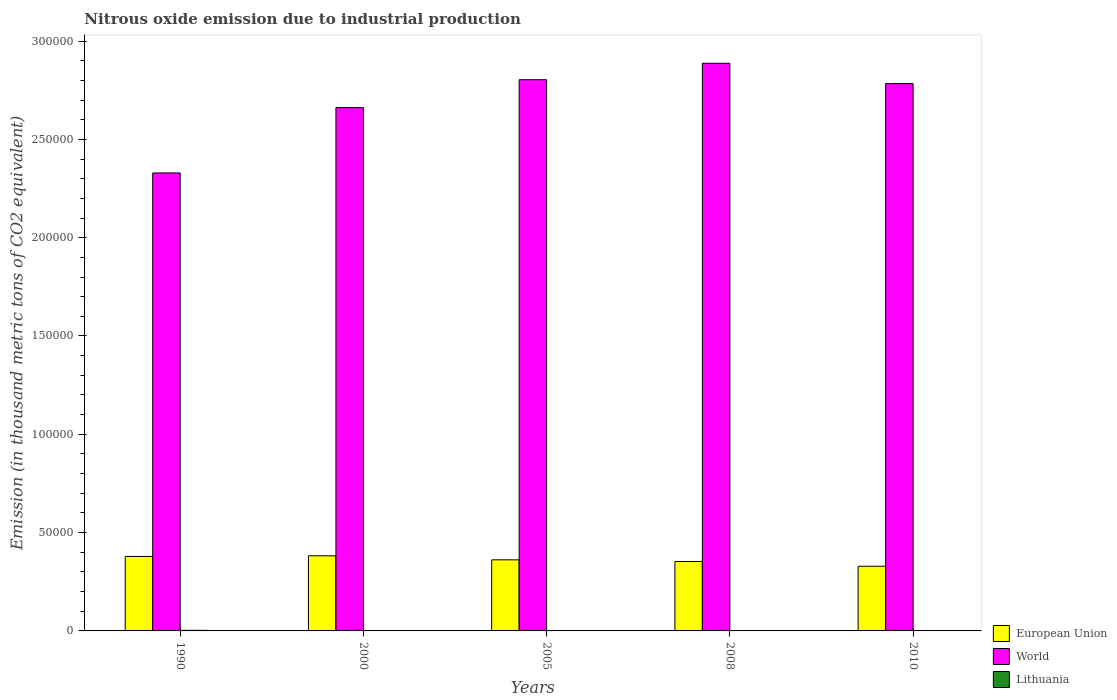How many different coloured bars are there?
Your response must be concise. 3. How many groups of bars are there?
Your response must be concise. 5. Are the number of bars per tick equal to the number of legend labels?
Give a very brief answer. Yes. Are the number of bars on each tick of the X-axis equal?
Provide a succinct answer. Yes. How many bars are there on the 1st tick from the left?
Give a very brief answer. 3. How many bars are there on the 5th tick from the right?
Your response must be concise. 3. In how many cases, is the number of bars for a given year not equal to the number of legend labels?
Provide a succinct answer. 0. What is the amount of nitrous oxide emitted in European Union in 2005?
Your answer should be very brief. 3.62e+04. Across all years, what is the maximum amount of nitrous oxide emitted in World?
Offer a terse response. 2.89e+05. Across all years, what is the minimum amount of nitrous oxide emitted in World?
Your answer should be compact. 2.33e+05. What is the total amount of nitrous oxide emitted in World in the graph?
Provide a short and direct response. 1.35e+06. What is the difference between the amount of nitrous oxide emitted in Lithuania in 2000 and that in 2010?
Offer a terse response. -2.5. What is the difference between the amount of nitrous oxide emitted in European Union in 2000 and the amount of nitrous oxide emitted in World in 2010?
Offer a very short reply. -2.40e+05. What is the average amount of nitrous oxide emitted in Lithuania per year?
Give a very brief answer. 153.16. In the year 2008, what is the difference between the amount of nitrous oxide emitted in Lithuania and amount of nitrous oxide emitted in European Union?
Make the answer very short. -3.52e+04. In how many years, is the amount of nitrous oxide emitted in Lithuania greater than 220000 thousand metric tons?
Your response must be concise. 0. What is the ratio of the amount of nitrous oxide emitted in European Union in 2000 to that in 2008?
Give a very brief answer. 1.08. What is the difference between the highest and the second highest amount of nitrous oxide emitted in European Union?
Give a very brief answer. 328.9. What is the difference between the highest and the lowest amount of nitrous oxide emitted in Lithuania?
Offer a terse response. 184.9. Is the sum of the amount of nitrous oxide emitted in World in 2000 and 2008 greater than the maximum amount of nitrous oxide emitted in European Union across all years?
Your answer should be compact. Yes. What does the 3rd bar from the left in 1990 represents?
Give a very brief answer. Lithuania. What does the 3rd bar from the right in 2010 represents?
Keep it short and to the point. European Union. Are all the bars in the graph horizontal?
Ensure brevity in your answer.  No. How many years are there in the graph?
Keep it short and to the point. 5. What is the difference between two consecutive major ticks on the Y-axis?
Ensure brevity in your answer.  5.00e+04. Does the graph contain any zero values?
Your response must be concise. No. Does the graph contain grids?
Ensure brevity in your answer.  No. Where does the legend appear in the graph?
Your answer should be compact. Bottom right. How many legend labels are there?
Make the answer very short. 3. How are the legend labels stacked?
Give a very brief answer. Vertical. What is the title of the graph?
Give a very brief answer. Nitrous oxide emission due to industrial production. Does "Syrian Arab Republic" appear as one of the legend labels in the graph?
Provide a short and direct response. No. What is the label or title of the X-axis?
Keep it short and to the point. Years. What is the label or title of the Y-axis?
Your answer should be compact. Emission (in thousand metric tons of CO2 equivalent). What is the Emission (in thousand metric tons of CO2 equivalent) of European Union in 1990?
Provide a succinct answer. 3.79e+04. What is the Emission (in thousand metric tons of CO2 equivalent) of World in 1990?
Make the answer very short. 2.33e+05. What is the Emission (in thousand metric tons of CO2 equivalent) of Lithuania in 1990?
Provide a succinct answer. 295.2. What is the Emission (in thousand metric tons of CO2 equivalent) of European Union in 2000?
Give a very brief answer. 3.82e+04. What is the Emission (in thousand metric tons of CO2 equivalent) in World in 2000?
Provide a short and direct response. 2.66e+05. What is the Emission (in thousand metric tons of CO2 equivalent) in Lithuania in 2000?
Make the answer very short. 110.3. What is the Emission (in thousand metric tons of CO2 equivalent) in European Union in 2005?
Your answer should be compact. 3.62e+04. What is the Emission (in thousand metric tons of CO2 equivalent) of World in 2005?
Give a very brief answer. 2.80e+05. What is the Emission (in thousand metric tons of CO2 equivalent) in Lithuania in 2005?
Your answer should be very brief. 119.6. What is the Emission (in thousand metric tons of CO2 equivalent) in European Union in 2008?
Your answer should be very brief. 3.53e+04. What is the Emission (in thousand metric tons of CO2 equivalent) of World in 2008?
Offer a terse response. 2.89e+05. What is the Emission (in thousand metric tons of CO2 equivalent) of Lithuania in 2008?
Your response must be concise. 127.9. What is the Emission (in thousand metric tons of CO2 equivalent) in European Union in 2010?
Make the answer very short. 3.29e+04. What is the Emission (in thousand metric tons of CO2 equivalent) of World in 2010?
Your answer should be very brief. 2.78e+05. What is the Emission (in thousand metric tons of CO2 equivalent) in Lithuania in 2010?
Ensure brevity in your answer.  112.8. Across all years, what is the maximum Emission (in thousand metric tons of CO2 equivalent) in European Union?
Ensure brevity in your answer.  3.82e+04. Across all years, what is the maximum Emission (in thousand metric tons of CO2 equivalent) in World?
Provide a short and direct response. 2.89e+05. Across all years, what is the maximum Emission (in thousand metric tons of CO2 equivalent) in Lithuania?
Provide a succinct answer. 295.2. Across all years, what is the minimum Emission (in thousand metric tons of CO2 equivalent) in European Union?
Your response must be concise. 3.29e+04. Across all years, what is the minimum Emission (in thousand metric tons of CO2 equivalent) of World?
Your answer should be compact. 2.33e+05. Across all years, what is the minimum Emission (in thousand metric tons of CO2 equivalent) in Lithuania?
Your response must be concise. 110.3. What is the total Emission (in thousand metric tons of CO2 equivalent) in European Union in the graph?
Your answer should be very brief. 1.80e+05. What is the total Emission (in thousand metric tons of CO2 equivalent) in World in the graph?
Offer a terse response. 1.35e+06. What is the total Emission (in thousand metric tons of CO2 equivalent) in Lithuania in the graph?
Provide a short and direct response. 765.8. What is the difference between the Emission (in thousand metric tons of CO2 equivalent) in European Union in 1990 and that in 2000?
Provide a succinct answer. -328.9. What is the difference between the Emission (in thousand metric tons of CO2 equivalent) in World in 1990 and that in 2000?
Keep it short and to the point. -3.32e+04. What is the difference between the Emission (in thousand metric tons of CO2 equivalent) of Lithuania in 1990 and that in 2000?
Keep it short and to the point. 184.9. What is the difference between the Emission (in thousand metric tons of CO2 equivalent) of European Union in 1990 and that in 2005?
Provide a short and direct response. 1721.7. What is the difference between the Emission (in thousand metric tons of CO2 equivalent) in World in 1990 and that in 2005?
Give a very brief answer. -4.74e+04. What is the difference between the Emission (in thousand metric tons of CO2 equivalent) in Lithuania in 1990 and that in 2005?
Your answer should be compact. 175.6. What is the difference between the Emission (in thousand metric tons of CO2 equivalent) of European Union in 1990 and that in 2008?
Keep it short and to the point. 2566.7. What is the difference between the Emission (in thousand metric tons of CO2 equivalent) of World in 1990 and that in 2008?
Your answer should be very brief. -5.58e+04. What is the difference between the Emission (in thousand metric tons of CO2 equivalent) in Lithuania in 1990 and that in 2008?
Your answer should be very brief. 167.3. What is the difference between the Emission (in thousand metric tons of CO2 equivalent) of European Union in 1990 and that in 2010?
Your response must be concise. 4969.2. What is the difference between the Emission (in thousand metric tons of CO2 equivalent) of World in 1990 and that in 2010?
Your answer should be very brief. -4.55e+04. What is the difference between the Emission (in thousand metric tons of CO2 equivalent) in Lithuania in 1990 and that in 2010?
Ensure brevity in your answer.  182.4. What is the difference between the Emission (in thousand metric tons of CO2 equivalent) in European Union in 2000 and that in 2005?
Your answer should be compact. 2050.6. What is the difference between the Emission (in thousand metric tons of CO2 equivalent) in World in 2000 and that in 2005?
Provide a succinct answer. -1.42e+04. What is the difference between the Emission (in thousand metric tons of CO2 equivalent) of Lithuania in 2000 and that in 2005?
Keep it short and to the point. -9.3. What is the difference between the Emission (in thousand metric tons of CO2 equivalent) of European Union in 2000 and that in 2008?
Give a very brief answer. 2895.6. What is the difference between the Emission (in thousand metric tons of CO2 equivalent) of World in 2000 and that in 2008?
Give a very brief answer. -2.25e+04. What is the difference between the Emission (in thousand metric tons of CO2 equivalent) in Lithuania in 2000 and that in 2008?
Provide a short and direct response. -17.6. What is the difference between the Emission (in thousand metric tons of CO2 equivalent) in European Union in 2000 and that in 2010?
Your answer should be compact. 5298.1. What is the difference between the Emission (in thousand metric tons of CO2 equivalent) of World in 2000 and that in 2010?
Your answer should be very brief. -1.22e+04. What is the difference between the Emission (in thousand metric tons of CO2 equivalent) of European Union in 2005 and that in 2008?
Provide a succinct answer. 845. What is the difference between the Emission (in thousand metric tons of CO2 equivalent) in World in 2005 and that in 2008?
Provide a short and direct response. -8372.6. What is the difference between the Emission (in thousand metric tons of CO2 equivalent) in Lithuania in 2005 and that in 2008?
Ensure brevity in your answer.  -8.3. What is the difference between the Emission (in thousand metric tons of CO2 equivalent) in European Union in 2005 and that in 2010?
Offer a terse response. 3247.5. What is the difference between the Emission (in thousand metric tons of CO2 equivalent) in World in 2005 and that in 2010?
Provide a short and direct response. 1963.1. What is the difference between the Emission (in thousand metric tons of CO2 equivalent) of Lithuania in 2005 and that in 2010?
Offer a terse response. 6.8. What is the difference between the Emission (in thousand metric tons of CO2 equivalent) of European Union in 2008 and that in 2010?
Your response must be concise. 2402.5. What is the difference between the Emission (in thousand metric tons of CO2 equivalent) of World in 2008 and that in 2010?
Offer a terse response. 1.03e+04. What is the difference between the Emission (in thousand metric tons of CO2 equivalent) of Lithuania in 2008 and that in 2010?
Give a very brief answer. 15.1. What is the difference between the Emission (in thousand metric tons of CO2 equivalent) of European Union in 1990 and the Emission (in thousand metric tons of CO2 equivalent) of World in 2000?
Your answer should be compact. -2.28e+05. What is the difference between the Emission (in thousand metric tons of CO2 equivalent) of European Union in 1990 and the Emission (in thousand metric tons of CO2 equivalent) of Lithuania in 2000?
Provide a succinct answer. 3.78e+04. What is the difference between the Emission (in thousand metric tons of CO2 equivalent) of World in 1990 and the Emission (in thousand metric tons of CO2 equivalent) of Lithuania in 2000?
Offer a terse response. 2.33e+05. What is the difference between the Emission (in thousand metric tons of CO2 equivalent) of European Union in 1990 and the Emission (in thousand metric tons of CO2 equivalent) of World in 2005?
Provide a succinct answer. -2.42e+05. What is the difference between the Emission (in thousand metric tons of CO2 equivalent) of European Union in 1990 and the Emission (in thousand metric tons of CO2 equivalent) of Lithuania in 2005?
Your response must be concise. 3.78e+04. What is the difference between the Emission (in thousand metric tons of CO2 equivalent) of World in 1990 and the Emission (in thousand metric tons of CO2 equivalent) of Lithuania in 2005?
Offer a very short reply. 2.33e+05. What is the difference between the Emission (in thousand metric tons of CO2 equivalent) of European Union in 1990 and the Emission (in thousand metric tons of CO2 equivalent) of World in 2008?
Your answer should be compact. -2.51e+05. What is the difference between the Emission (in thousand metric tons of CO2 equivalent) of European Union in 1990 and the Emission (in thousand metric tons of CO2 equivalent) of Lithuania in 2008?
Make the answer very short. 3.77e+04. What is the difference between the Emission (in thousand metric tons of CO2 equivalent) in World in 1990 and the Emission (in thousand metric tons of CO2 equivalent) in Lithuania in 2008?
Offer a very short reply. 2.33e+05. What is the difference between the Emission (in thousand metric tons of CO2 equivalent) of European Union in 1990 and the Emission (in thousand metric tons of CO2 equivalent) of World in 2010?
Offer a terse response. -2.40e+05. What is the difference between the Emission (in thousand metric tons of CO2 equivalent) of European Union in 1990 and the Emission (in thousand metric tons of CO2 equivalent) of Lithuania in 2010?
Your answer should be compact. 3.78e+04. What is the difference between the Emission (in thousand metric tons of CO2 equivalent) of World in 1990 and the Emission (in thousand metric tons of CO2 equivalent) of Lithuania in 2010?
Keep it short and to the point. 2.33e+05. What is the difference between the Emission (in thousand metric tons of CO2 equivalent) in European Union in 2000 and the Emission (in thousand metric tons of CO2 equivalent) in World in 2005?
Your response must be concise. -2.42e+05. What is the difference between the Emission (in thousand metric tons of CO2 equivalent) in European Union in 2000 and the Emission (in thousand metric tons of CO2 equivalent) in Lithuania in 2005?
Your answer should be very brief. 3.81e+04. What is the difference between the Emission (in thousand metric tons of CO2 equivalent) in World in 2000 and the Emission (in thousand metric tons of CO2 equivalent) in Lithuania in 2005?
Your response must be concise. 2.66e+05. What is the difference between the Emission (in thousand metric tons of CO2 equivalent) in European Union in 2000 and the Emission (in thousand metric tons of CO2 equivalent) in World in 2008?
Your answer should be very brief. -2.51e+05. What is the difference between the Emission (in thousand metric tons of CO2 equivalent) in European Union in 2000 and the Emission (in thousand metric tons of CO2 equivalent) in Lithuania in 2008?
Make the answer very short. 3.81e+04. What is the difference between the Emission (in thousand metric tons of CO2 equivalent) of World in 2000 and the Emission (in thousand metric tons of CO2 equivalent) of Lithuania in 2008?
Provide a succinct answer. 2.66e+05. What is the difference between the Emission (in thousand metric tons of CO2 equivalent) of European Union in 2000 and the Emission (in thousand metric tons of CO2 equivalent) of World in 2010?
Your response must be concise. -2.40e+05. What is the difference between the Emission (in thousand metric tons of CO2 equivalent) in European Union in 2000 and the Emission (in thousand metric tons of CO2 equivalent) in Lithuania in 2010?
Offer a terse response. 3.81e+04. What is the difference between the Emission (in thousand metric tons of CO2 equivalent) of World in 2000 and the Emission (in thousand metric tons of CO2 equivalent) of Lithuania in 2010?
Provide a short and direct response. 2.66e+05. What is the difference between the Emission (in thousand metric tons of CO2 equivalent) in European Union in 2005 and the Emission (in thousand metric tons of CO2 equivalent) in World in 2008?
Give a very brief answer. -2.53e+05. What is the difference between the Emission (in thousand metric tons of CO2 equivalent) of European Union in 2005 and the Emission (in thousand metric tons of CO2 equivalent) of Lithuania in 2008?
Keep it short and to the point. 3.60e+04. What is the difference between the Emission (in thousand metric tons of CO2 equivalent) of World in 2005 and the Emission (in thousand metric tons of CO2 equivalent) of Lithuania in 2008?
Offer a very short reply. 2.80e+05. What is the difference between the Emission (in thousand metric tons of CO2 equivalent) of European Union in 2005 and the Emission (in thousand metric tons of CO2 equivalent) of World in 2010?
Your answer should be compact. -2.42e+05. What is the difference between the Emission (in thousand metric tons of CO2 equivalent) of European Union in 2005 and the Emission (in thousand metric tons of CO2 equivalent) of Lithuania in 2010?
Ensure brevity in your answer.  3.60e+04. What is the difference between the Emission (in thousand metric tons of CO2 equivalent) of World in 2005 and the Emission (in thousand metric tons of CO2 equivalent) of Lithuania in 2010?
Give a very brief answer. 2.80e+05. What is the difference between the Emission (in thousand metric tons of CO2 equivalent) in European Union in 2008 and the Emission (in thousand metric tons of CO2 equivalent) in World in 2010?
Give a very brief answer. -2.43e+05. What is the difference between the Emission (in thousand metric tons of CO2 equivalent) of European Union in 2008 and the Emission (in thousand metric tons of CO2 equivalent) of Lithuania in 2010?
Offer a very short reply. 3.52e+04. What is the difference between the Emission (in thousand metric tons of CO2 equivalent) in World in 2008 and the Emission (in thousand metric tons of CO2 equivalent) in Lithuania in 2010?
Offer a terse response. 2.89e+05. What is the average Emission (in thousand metric tons of CO2 equivalent) in European Union per year?
Offer a very short reply. 3.61e+04. What is the average Emission (in thousand metric tons of CO2 equivalent) of World per year?
Provide a short and direct response. 2.69e+05. What is the average Emission (in thousand metric tons of CO2 equivalent) in Lithuania per year?
Keep it short and to the point. 153.16. In the year 1990, what is the difference between the Emission (in thousand metric tons of CO2 equivalent) of European Union and Emission (in thousand metric tons of CO2 equivalent) of World?
Keep it short and to the point. -1.95e+05. In the year 1990, what is the difference between the Emission (in thousand metric tons of CO2 equivalent) in European Union and Emission (in thousand metric tons of CO2 equivalent) in Lithuania?
Provide a succinct answer. 3.76e+04. In the year 1990, what is the difference between the Emission (in thousand metric tons of CO2 equivalent) in World and Emission (in thousand metric tons of CO2 equivalent) in Lithuania?
Ensure brevity in your answer.  2.33e+05. In the year 2000, what is the difference between the Emission (in thousand metric tons of CO2 equivalent) in European Union and Emission (in thousand metric tons of CO2 equivalent) in World?
Offer a very short reply. -2.28e+05. In the year 2000, what is the difference between the Emission (in thousand metric tons of CO2 equivalent) of European Union and Emission (in thousand metric tons of CO2 equivalent) of Lithuania?
Your answer should be very brief. 3.81e+04. In the year 2000, what is the difference between the Emission (in thousand metric tons of CO2 equivalent) of World and Emission (in thousand metric tons of CO2 equivalent) of Lithuania?
Offer a very short reply. 2.66e+05. In the year 2005, what is the difference between the Emission (in thousand metric tons of CO2 equivalent) of European Union and Emission (in thousand metric tons of CO2 equivalent) of World?
Give a very brief answer. -2.44e+05. In the year 2005, what is the difference between the Emission (in thousand metric tons of CO2 equivalent) in European Union and Emission (in thousand metric tons of CO2 equivalent) in Lithuania?
Your response must be concise. 3.60e+04. In the year 2005, what is the difference between the Emission (in thousand metric tons of CO2 equivalent) of World and Emission (in thousand metric tons of CO2 equivalent) of Lithuania?
Your answer should be compact. 2.80e+05. In the year 2008, what is the difference between the Emission (in thousand metric tons of CO2 equivalent) in European Union and Emission (in thousand metric tons of CO2 equivalent) in World?
Offer a very short reply. -2.53e+05. In the year 2008, what is the difference between the Emission (in thousand metric tons of CO2 equivalent) of European Union and Emission (in thousand metric tons of CO2 equivalent) of Lithuania?
Your answer should be very brief. 3.52e+04. In the year 2008, what is the difference between the Emission (in thousand metric tons of CO2 equivalent) in World and Emission (in thousand metric tons of CO2 equivalent) in Lithuania?
Offer a terse response. 2.89e+05. In the year 2010, what is the difference between the Emission (in thousand metric tons of CO2 equivalent) in European Union and Emission (in thousand metric tons of CO2 equivalent) in World?
Give a very brief answer. -2.45e+05. In the year 2010, what is the difference between the Emission (in thousand metric tons of CO2 equivalent) in European Union and Emission (in thousand metric tons of CO2 equivalent) in Lithuania?
Your answer should be compact. 3.28e+04. In the year 2010, what is the difference between the Emission (in thousand metric tons of CO2 equivalent) of World and Emission (in thousand metric tons of CO2 equivalent) of Lithuania?
Your answer should be compact. 2.78e+05. What is the ratio of the Emission (in thousand metric tons of CO2 equivalent) of European Union in 1990 to that in 2000?
Keep it short and to the point. 0.99. What is the ratio of the Emission (in thousand metric tons of CO2 equivalent) of World in 1990 to that in 2000?
Your answer should be very brief. 0.88. What is the ratio of the Emission (in thousand metric tons of CO2 equivalent) in Lithuania in 1990 to that in 2000?
Provide a short and direct response. 2.68. What is the ratio of the Emission (in thousand metric tons of CO2 equivalent) of European Union in 1990 to that in 2005?
Keep it short and to the point. 1.05. What is the ratio of the Emission (in thousand metric tons of CO2 equivalent) of World in 1990 to that in 2005?
Provide a succinct answer. 0.83. What is the ratio of the Emission (in thousand metric tons of CO2 equivalent) of Lithuania in 1990 to that in 2005?
Your answer should be very brief. 2.47. What is the ratio of the Emission (in thousand metric tons of CO2 equivalent) of European Union in 1990 to that in 2008?
Provide a succinct answer. 1.07. What is the ratio of the Emission (in thousand metric tons of CO2 equivalent) in World in 1990 to that in 2008?
Give a very brief answer. 0.81. What is the ratio of the Emission (in thousand metric tons of CO2 equivalent) in Lithuania in 1990 to that in 2008?
Offer a terse response. 2.31. What is the ratio of the Emission (in thousand metric tons of CO2 equivalent) of European Union in 1990 to that in 2010?
Ensure brevity in your answer.  1.15. What is the ratio of the Emission (in thousand metric tons of CO2 equivalent) in World in 1990 to that in 2010?
Keep it short and to the point. 0.84. What is the ratio of the Emission (in thousand metric tons of CO2 equivalent) of Lithuania in 1990 to that in 2010?
Your answer should be compact. 2.62. What is the ratio of the Emission (in thousand metric tons of CO2 equivalent) in European Union in 2000 to that in 2005?
Your answer should be compact. 1.06. What is the ratio of the Emission (in thousand metric tons of CO2 equivalent) in World in 2000 to that in 2005?
Provide a short and direct response. 0.95. What is the ratio of the Emission (in thousand metric tons of CO2 equivalent) in Lithuania in 2000 to that in 2005?
Your response must be concise. 0.92. What is the ratio of the Emission (in thousand metric tons of CO2 equivalent) of European Union in 2000 to that in 2008?
Provide a succinct answer. 1.08. What is the ratio of the Emission (in thousand metric tons of CO2 equivalent) of World in 2000 to that in 2008?
Offer a terse response. 0.92. What is the ratio of the Emission (in thousand metric tons of CO2 equivalent) of Lithuania in 2000 to that in 2008?
Provide a succinct answer. 0.86. What is the ratio of the Emission (in thousand metric tons of CO2 equivalent) in European Union in 2000 to that in 2010?
Provide a succinct answer. 1.16. What is the ratio of the Emission (in thousand metric tons of CO2 equivalent) in World in 2000 to that in 2010?
Your response must be concise. 0.96. What is the ratio of the Emission (in thousand metric tons of CO2 equivalent) in Lithuania in 2000 to that in 2010?
Ensure brevity in your answer.  0.98. What is the ratio of the Emission (in thousand metric tons of CO2 equivalent) in European Union in 2005 to that in 2008?
Keep it short and to the point. 1.02. What is the ratio of the Emission (in thousand metric tons of CO2 equivalent) of World in 2005 to that in 2008?
Your response must be concise. 0.97. What is the ratio of the Emission (in thousand metric tons of CO2 equivalent) of Lithuania in 2005 to that in 2008?
Provide a succinct answer. 0.94. What is the ratio of the Emission (in thousand metric tons of CO2 equivalent) of European Union in 2005 to that in 2010?
Your response must be concise. 1.1. What is the ratio of the Emission (in thousand metric tons of CO2 equivalent) in World in 2005 to that in 2010?
Provide a succinct answer. 1.01. What is the ratio of the Emission (in thousand metric tons of CO2 equivalent) of Lithuania in 2005 to that in 2010?
Your response must be concise. 1.06. What is the ratio of the Emission (in thousand metric tons of CO2 equivalent) of European Union in 2008 to that in 2010?
Ensure brevity in your answer.  1.07. What is the ratio of the Emission (in thousand metric tons of CO2 equivalent) of World in 2008 to that in 2010?
Keep it short and to the point. 1.04. What is the ratio of the Emission (in thousand metric tons of CO2 equivalent) in Lithuania in 2008 to that in 2010?
Make the answer very short. 1.13. What is the difference between the highest and the second highest Emission (in thousand metric tons of CO2 equivalent) of European Union?
Offer a terse response. 328.9. What is the difference between the highest and the second highest Emission (in thousand metric tons of CO2 equivalent) of World?
Offer a very short reply. 8372.6. What is the difference between the highest and the second highest Emission (in thousand metric tons of CO2 equivalent) in Lithuania?
Provide a short and direct response. 167.3. What is the difference between the highest and the lowest Emission (in thousand metric tons of CO2 equivalent) of European Union?
Your answer should be very brief. 5298.1. What is the difference between the highest and the lowest Emission (in thousand metric tons of CO2 equivalent) in World?
Keep it short and to the point. 5.58e+04. What is the difference between the highest and the lowest Emission (in thousand metric tons of CO2 equivalent) in Lithuania?
Ensure brevity in your answer.  184.9. 